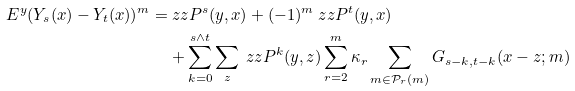Convert formula to latex. <formula><loc_0><loc_0><loc_500><loc_500>E ^ { y } ( Y _ { s } ( x ) - Y _ { t } ( x ) ) ^ { m } = & \ z z { P } ^ { s } ( y , x ) + ( - 1 ) ^ { m } \ z z { P } ^ { t } ( y , x ) \\ & + \sum _ { k = 0 } ^ { s \wedge t } \sum _ { z } \ z z { P } ^ { k } ( y , z ) \sum _ { r = 2 } ^ { m } \kappa _ { r } \sum _ { m \in \mathcal { P } _ { r } ( m ) } G _ { s - k , t - k } ( x - z ; m )</formula> 